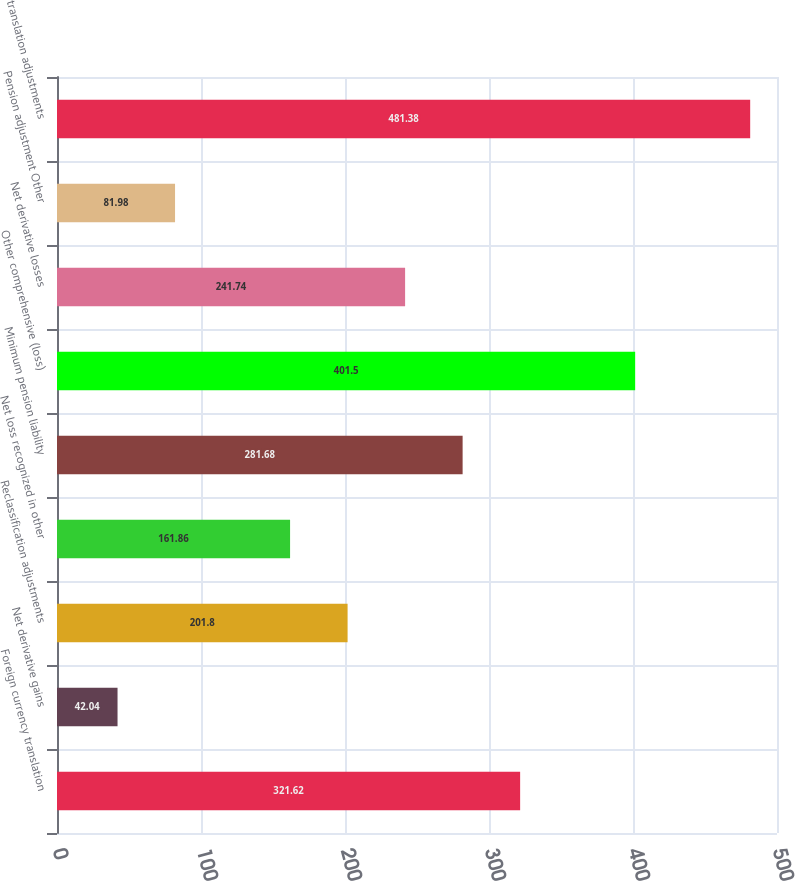Convert chart to OTSL. <chart><loc_0><loc_0><loc_500><loc_500><bar_chart><fcel>Foreign currency translation<fcel>Net derivative gains<fcel>Reclassification adjustments<fcel>Net loss recognized in other<fcel>Minimum pension liability<fcel>Other comprehensive (loss)<fcel>Net derivative losses<fcel>Pension adjustment Other<fcel>translation adjustments<nl><fcel>321.62<fcel>42.04<fcel>201.8<fcel>161.86<fcel>281.68<fcel>401.5<fcel>241.74<fcel>81.98<fcel>481.38<nl></chart> 